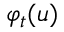Convert formula to latex. <formula><loc_0><loc_0><loc_500><loc_500>\varphi _ { t } ( u )</formula> 